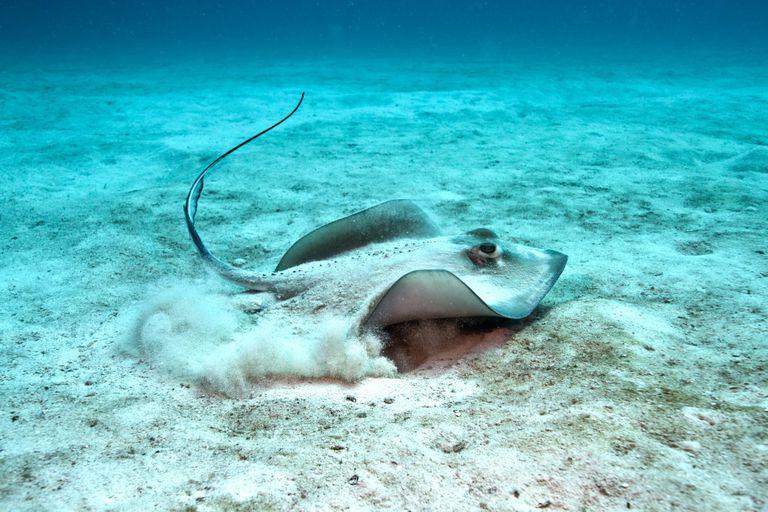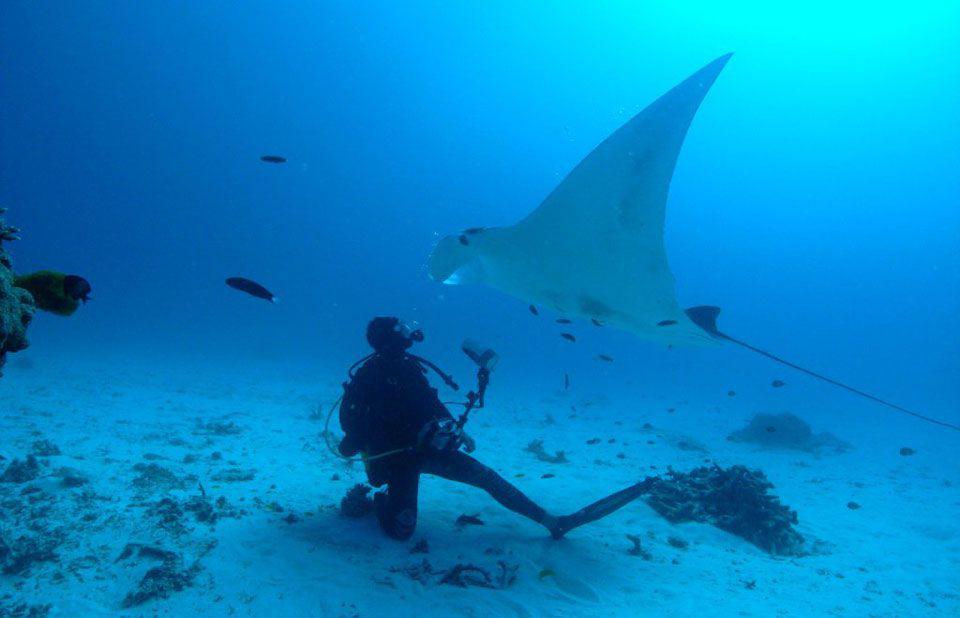The first image is the image on the left, the second image is the image on the right. Examine the images to the left and right. Is the description "The left and right image contains the same number stingrays with at least one with blue dots." accurate? Answer yes or no. No. The first image is the image on the left, the second image is the image on the right. For the images shown, is this caption "The ocean floor is visible in both images." true? Answer yes or no. Yes. 